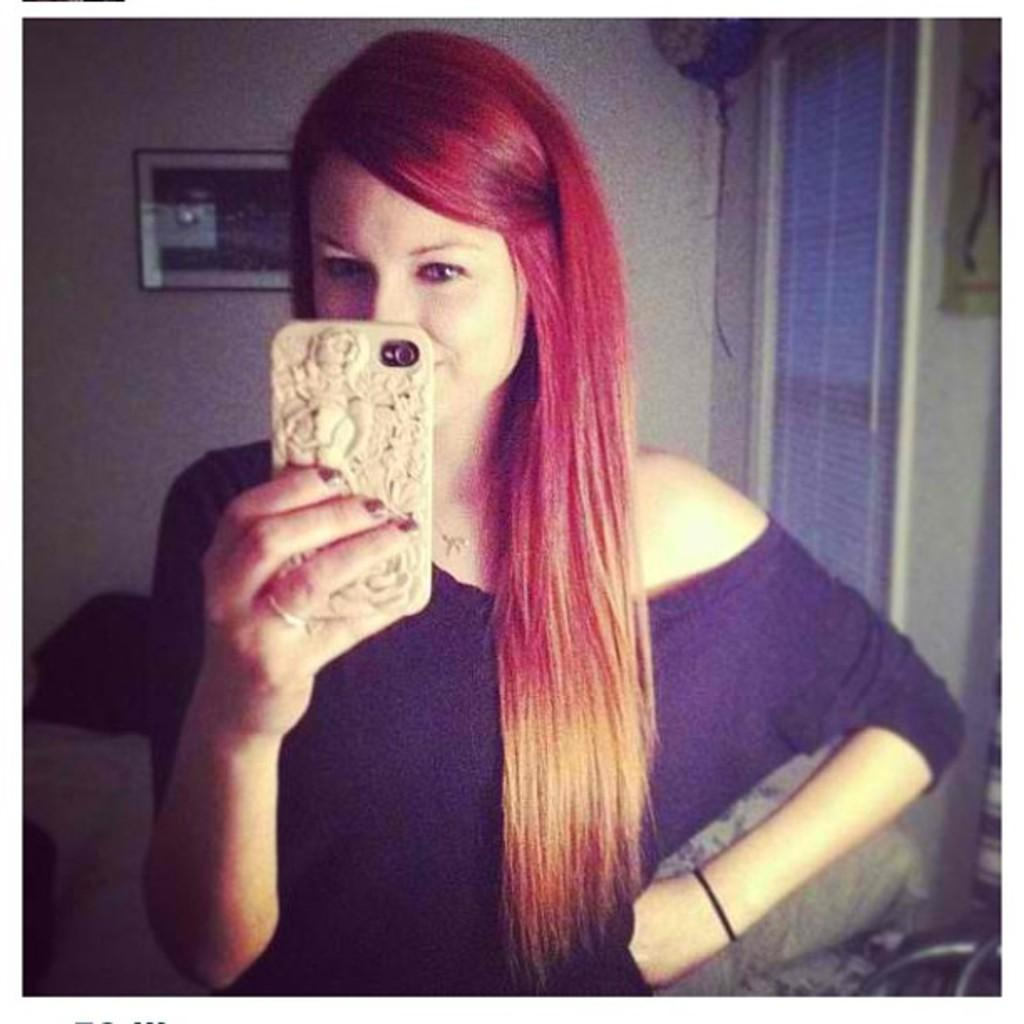Who is the main subject in the image? There is a lady standing in the center of the image. What is the lady holding in her hand? The lady is holding a mobile. What can be seen in the background of the image? There is a wall and a window in the background of the image. What is placed on the wall in the background? There is a frame placed on the wall in the background. How many feet are visible in the image? There is no mention of feet in the image, as the focus is on the lady holding a mobile and the background elements. 